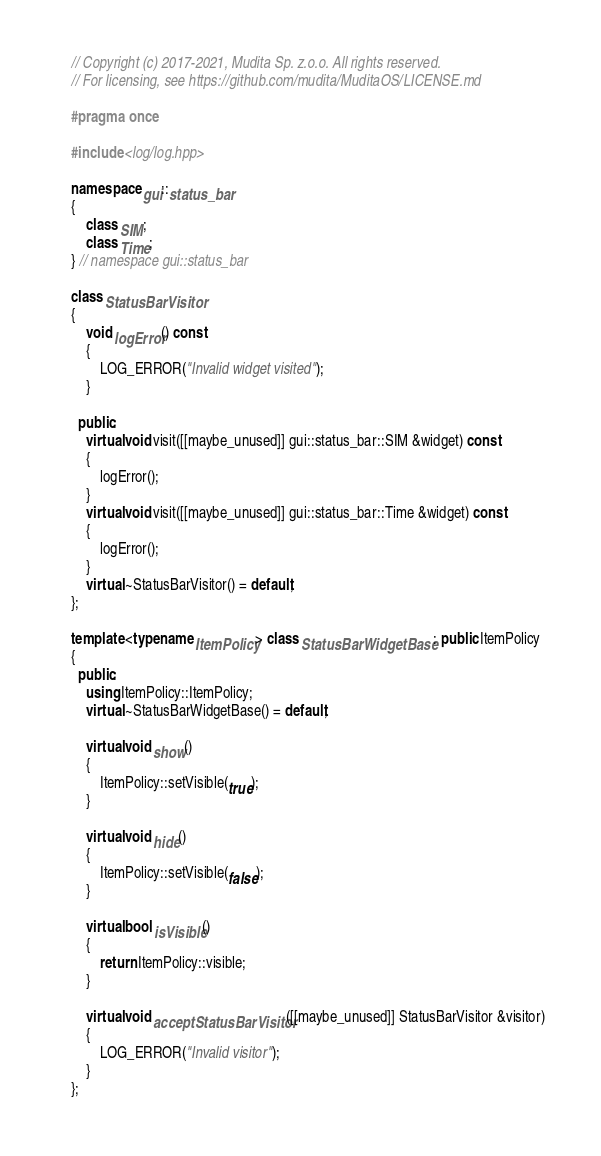Convert code to text. <code><loc_0><loc_0><loc_500><loc_500><_C++_>// Copyright (c) 2017-2021, Mudita Sp. z.o.o. All rights reserved.
// For licensing, see https://github.com/mudita/MuditaOS/LICENSE.md

#pragma once

#include <log/log.hpp>

namespace gui::status_bar
{
    class SIM;
    class Time;
} // namespace gui::status_bar

class StatusBarVisitor
{
    void logError() const
    {
        LOG_ERROR("Invalid widget visited");
    }

  public:
    virtual void visit([[maybe_unused]] gui::status_bar::SIM &widget) const
    {
        logError();
    }
    virtual void visit([[maybe_unused]] gui::status_bar::Time &widget) const
    {
        logError();
    }
    virtual ~StatusBarVisitor() = default;
};

template <typename ItemPolicy> class StatusBarWidgetBase : public ItemPolicy
{
  public:
    using ItemPolicy::ItemPolicy;
    virtual ~StatusBarWidgetBase() = default;

    virtual void show()
    {
        ItemPolicy::setVisible(true);
    }

    virtual void hide()
    {
        ItemPolicy::setVisible(false);
    }

    virtual bool isVisible()
    {
        return ItemPolicy::visible;
    }

    virtual void acceptStatusBarVisitor([[maybe_unused]] StatusBarVisitor &visitor)
    {
        LOG_ERROR("Invalid visitor");
    }
};
</code> 